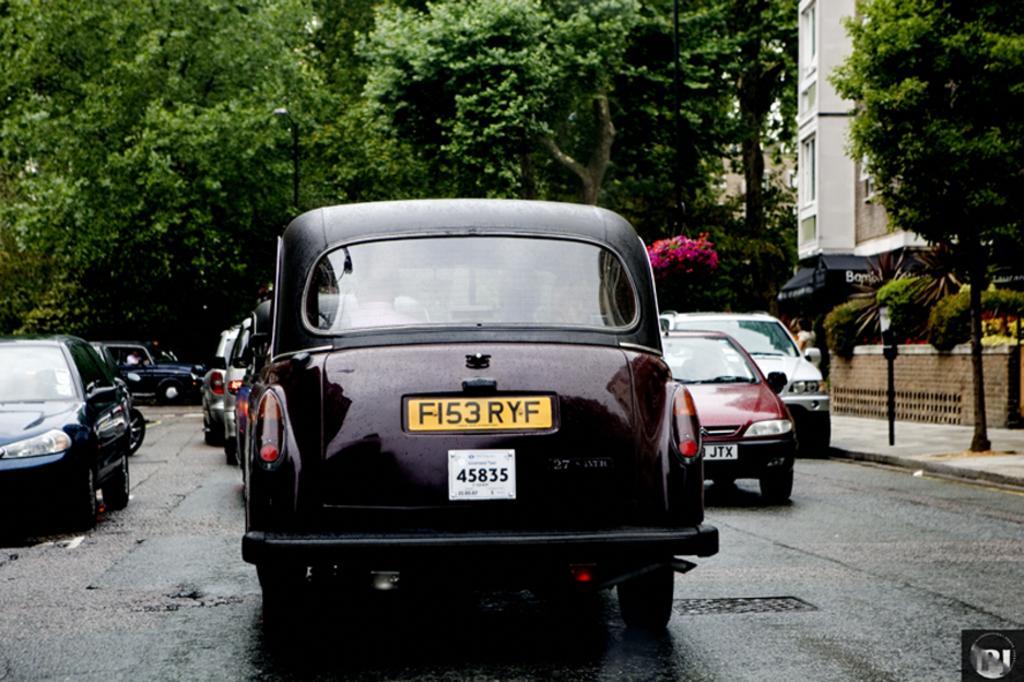Could you give a brief overview of what you see in this image? In the image there are different types of cars moving on the road and in the right side there is a footpath and beside the footpath there is a building and there are plenty of trees around the building. 